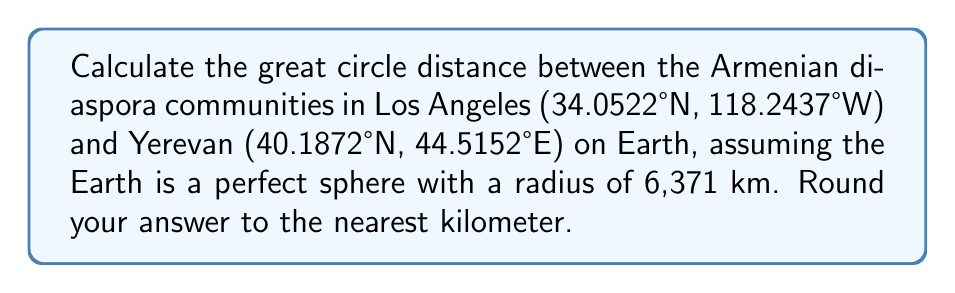Solve this math problem. To calculate the great circle distance between two points on a sphere, we can use the spherical law of cosines formula:

$$d = R \cdot \arccos(\sin(\phi_1) \sin(\phi_2) + \cos(\phi_1) \cos(\phi_2) \cos(\Delta \lambda))$$

Where:
- $d$ is the distance
- $R$ is the radius of the Earth
- $\phi_1, \phi_2$ are the latitudes of the two points
- $\Delta \lambda$ is the difference in longitude

Step 1: Convert the coordinates to radians
Los Angeles: $\phi_1 = 34.0522° \cdot \frac{\pi}{180} = 0.5942$ rad
             $\lambda_1 = -118.2437° \cdot \frac{\pi}{180} = -2.0638$ rad
Yerevan:     $\phi_2 = 40.1872° \cdot \frac{\pi}{180} = 0.7014$ rad
             $\lambda_2 = 44.5152° \cdot \frac{\pi}{180} = 0.7769$ rad

Step 2: Calculate $\Delta \lambda$
$\Delta \lambda = \lambda_2 - \lambda_1 = 0.7769 - (-2.0638) = 2.8407$ rad

Step 3: Apply the formula
$d = 6371 \cdot \arccos(\sin(0.5942) \sin(0.7014) + \cos(0.5942) \cos(0.7014) \cos(2.8407))$

Step 4: Calculate and round to the nearest kilometer
$d \approx 11,348.5$ km
Rounding to the nearest kilometer: 11,349 km
Answer: 11,349 km 